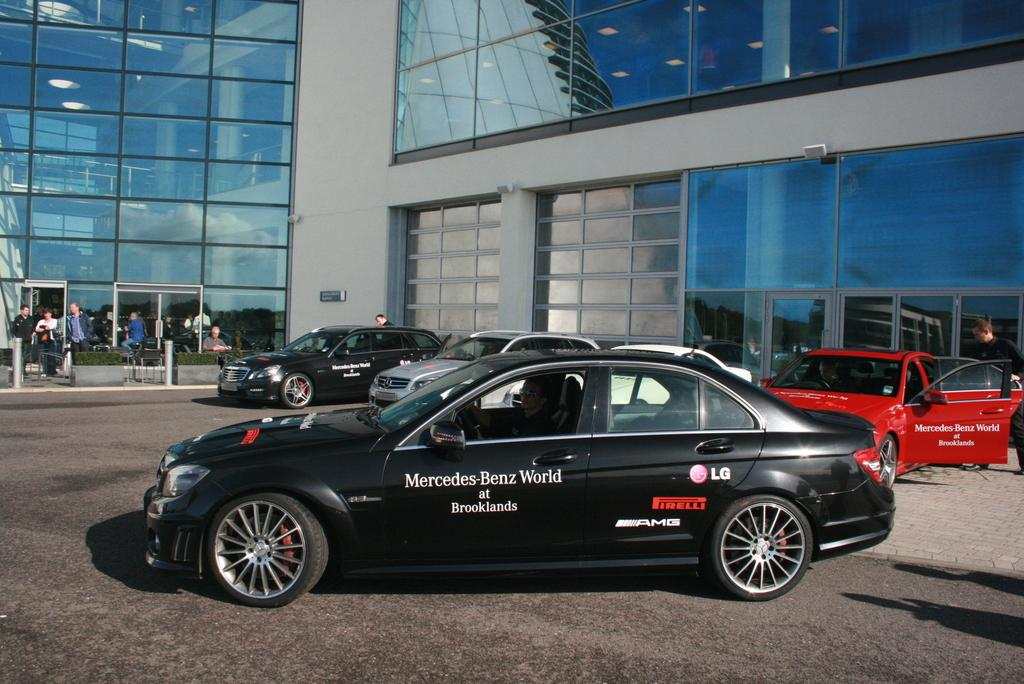What is located in the middle of the image? There are vehicles in the middle of the image. What can be seen behind the vehicles? There are plants and people standing and walking behind the vehicles. What is visible at the top of the image? There is a building visible at the top of the image. What type of soup is being served in the vehicles? There is no soup present in the image; it features vehicles, plants, people, and a building. How many bikes are visible in the image? There is no mention of bikes in the image; it only includes vehicles, plants, people, and a building. 